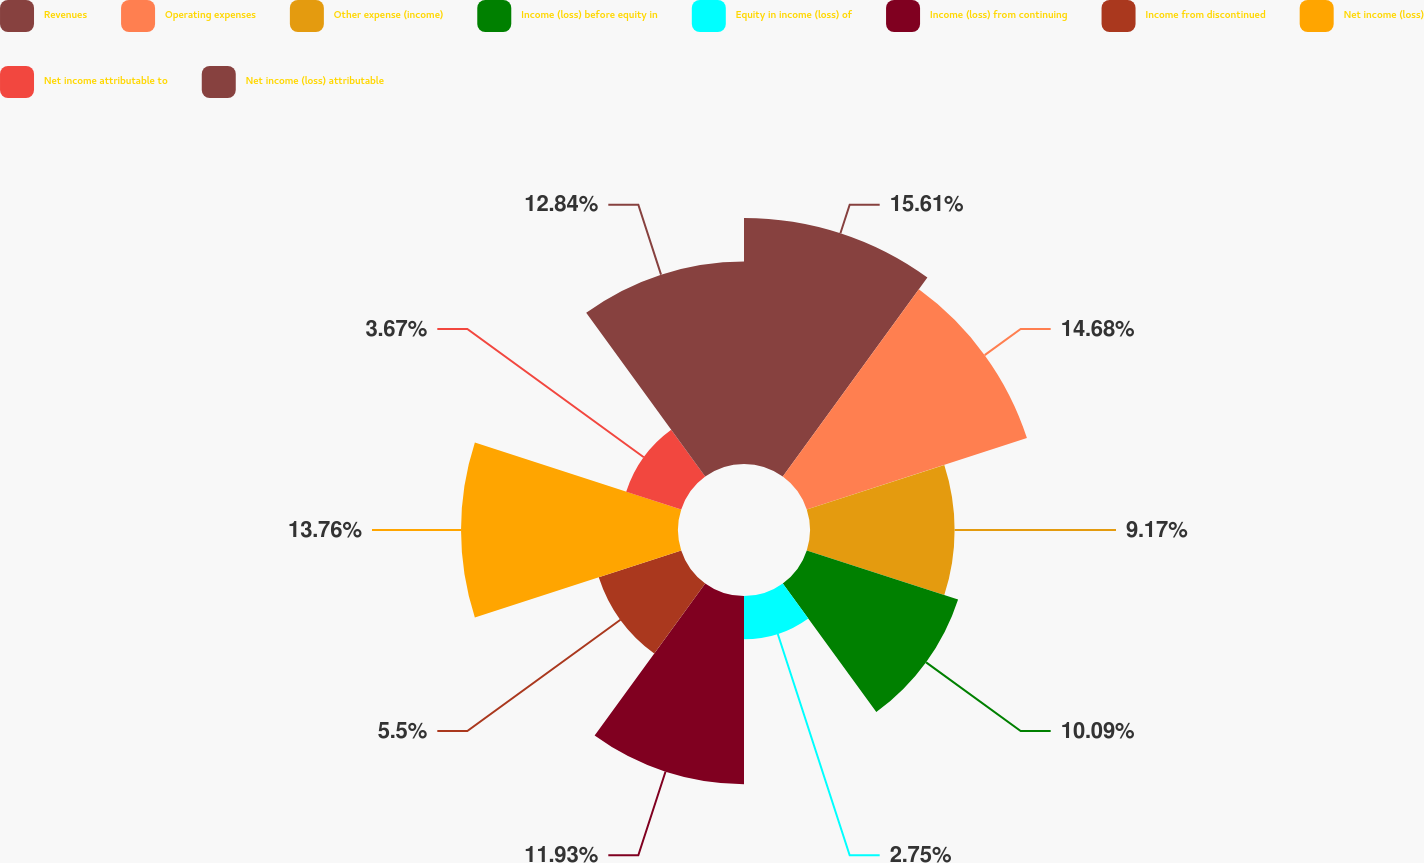Convert chart to OTSL. <chart><loc_0><loc_0><loc_500><loc_500><pie_chart><fcel>Revenues<fcel>Operating expenses<fcel>Other expense (income)<fcel>Income (loss) before equity in<fcel>Equity in income (loss) of<fcel>Income (loss) from continuing<fcel>Income from discontinued<fcel>Net income (loss)<fcel>Net income attributable to<fcel>Net income (loss) attributable<nl><fcel>15.6%<fcel>14.68%<fcel>9.17%<fcel>10.09%<fcel>2.75%<fcel>11.93%<fcel>5.5%<fcel>13.76%<fcel>3.67%<fcel>12.84%<nl></chart> 